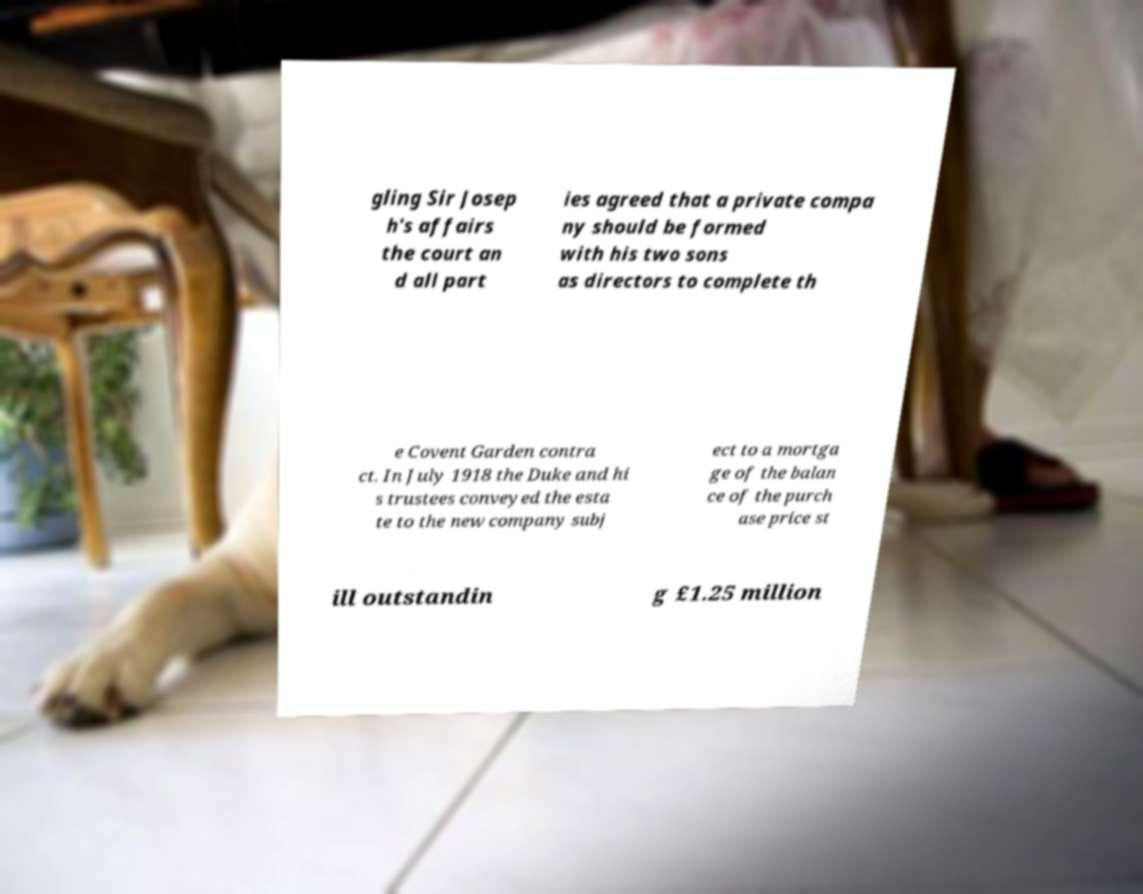Can you accurately transcribe the text from the provided image for me? gling Sir Josep h's affairs the court an d all part ies agreed that a private compa ny should be formed with his two sons as directors to complete th e Covent Garden contra ct. In July 1918 the Duke and hi s trustees conveyed the esta te to the new company subj ect to a mortga ge of the balan ce of the purch ase price st ill outstandin g £1.25 million 